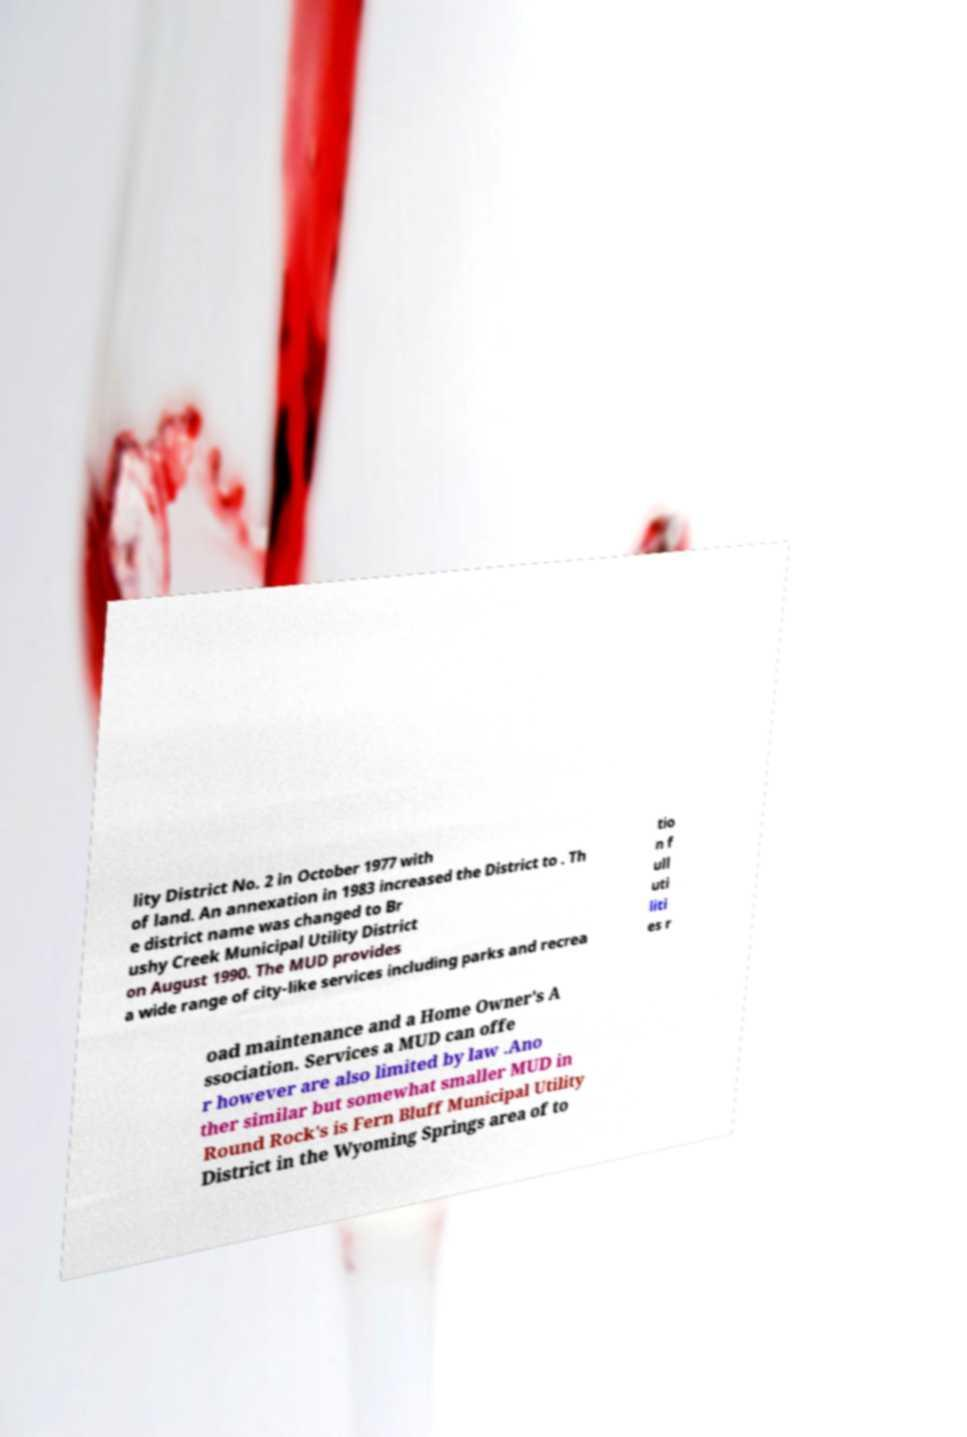I need the written content from this picture converted into text. Can you do that? lity District No. 2 in October 1977 with of land. An annexation in 1983 increased the District to . Th e district name was changed to Br ushy Creek Municipal Utility District on August 1990. The MUD provides a wide range of city-like services including parks and recrea tio n f ull uti liti es r oad maintenance and a Home Owner's A ssociation. Services a MUD can offe r however are also limited by law .Ano ther similar but somewhat smaller MUD in Round Rock's is Fern Bluff Municipal Utility District in the Wyoming Springs area of to 